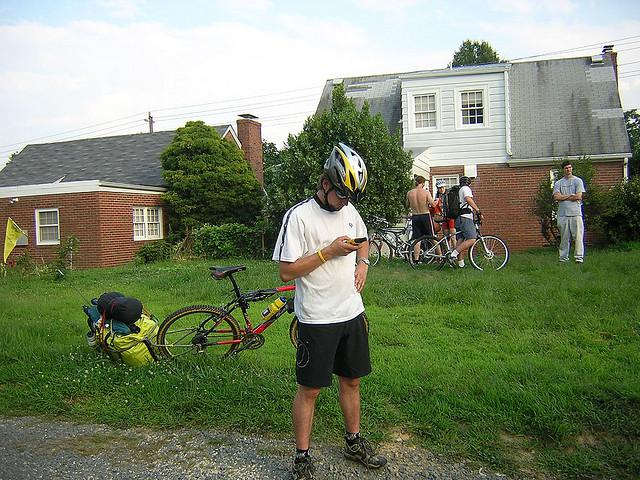Why is the man looking down at his hand? Please explain your reasoning. answering phone. The man is checking his cell. 